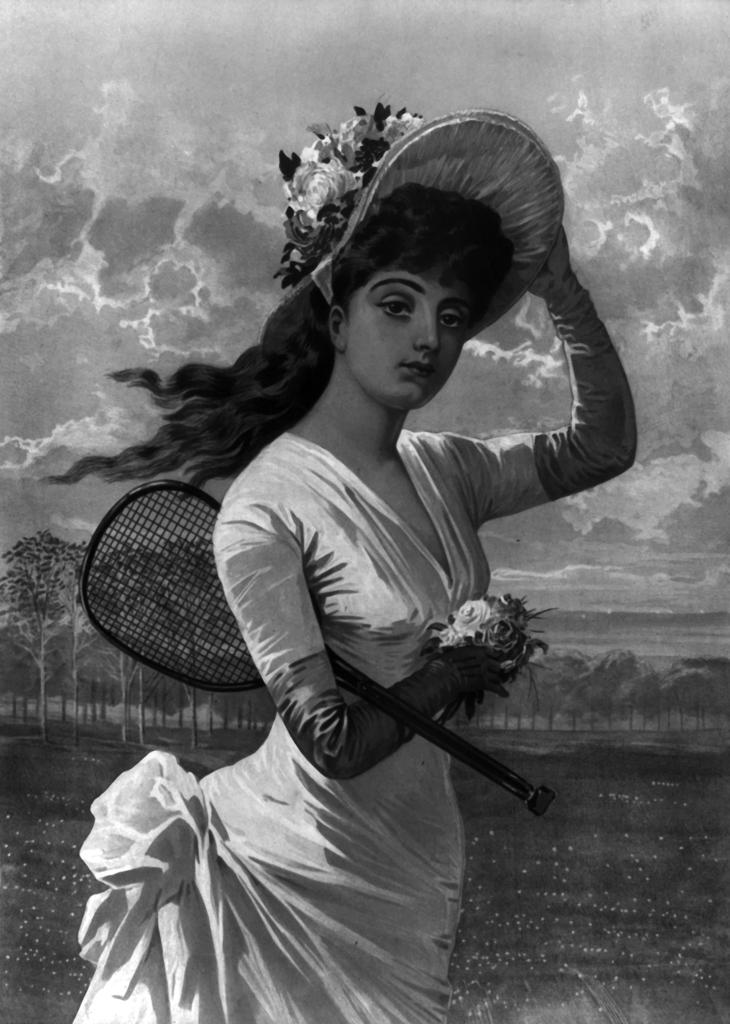What is the main subject of the image? There is a person in the image. What is the person doing in the image? The person is standing and holding a bat. What other elements can be seen in the image? There are flowers, trees, and the sky visible in the image. What is the color scheme of the image? The image is in black and white. What type of treatment is being administered to the flowers in the image? There is no treatment being administered to the flowers in the image; they are simply present in the scene. What kind of fuel is being used by the person holding the bat in the image? There is no mention of fuel in the image, as the person is holding a bat, which does not require fuel. 